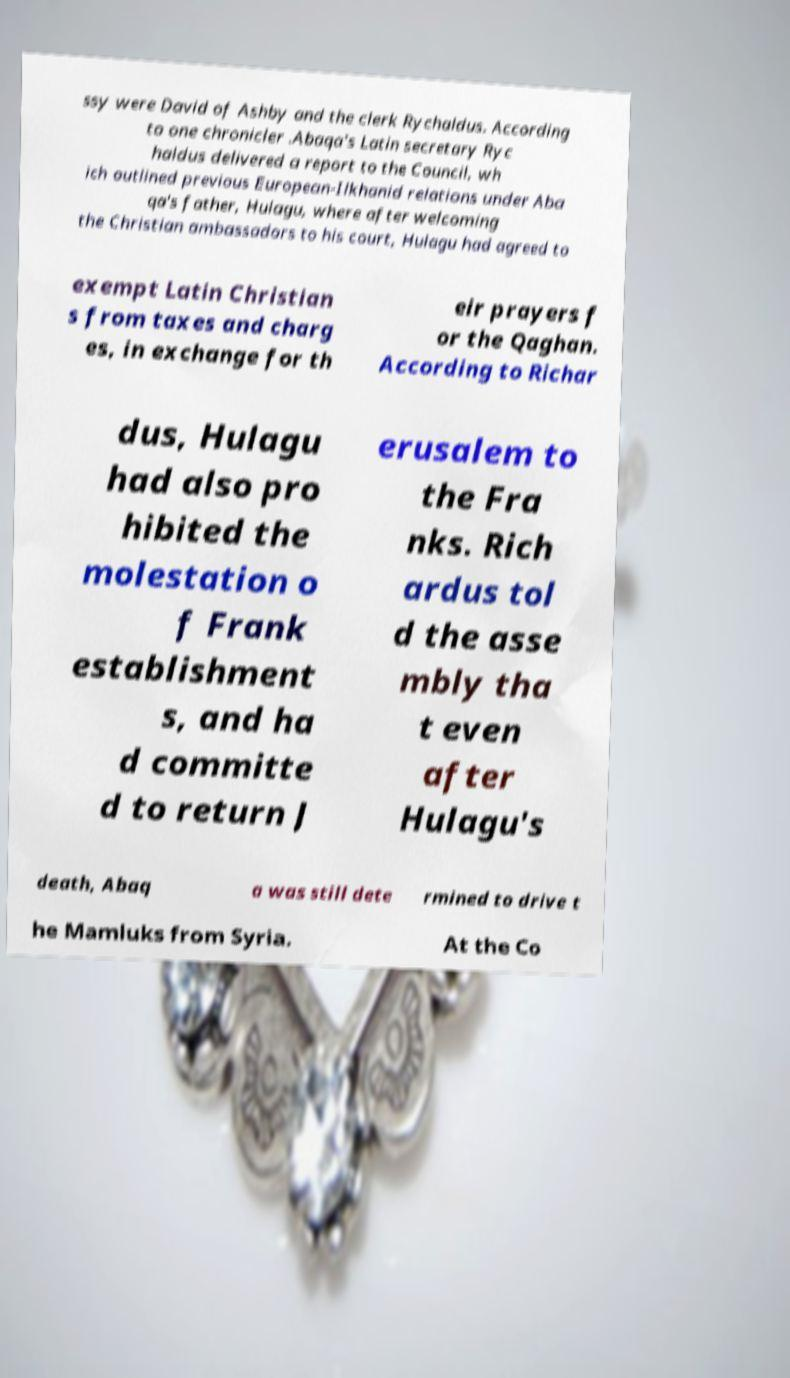Could you assist in decoding the text presented in this image and type it out clearly? ssy were David of Ashby and the clerk Rychaldus. According to one chronicler .Abaqa's Latin secretary Ryc haldus delivered a report to the Council, wh ich outlined previous European-Ilkhanid relations under Aba qa's father, Hulagu, where after welcoming the Christian ambassadors to his court, Hulagu had agreed to exempt Latin Christian s from taxes and charg es, in exchange for th eir prayers f or the Qaghan. According to Richar dus, Hulagu had also pro hibited the molestation o f Frank establishment s, and ha d committe d to return J erusalem to the Fra nks. Rich ardus tol d the asse mbly tha t even after Hulagu's death, Abaq a was still dete rmined to drive t he Mamluks from Syria. At the Co 